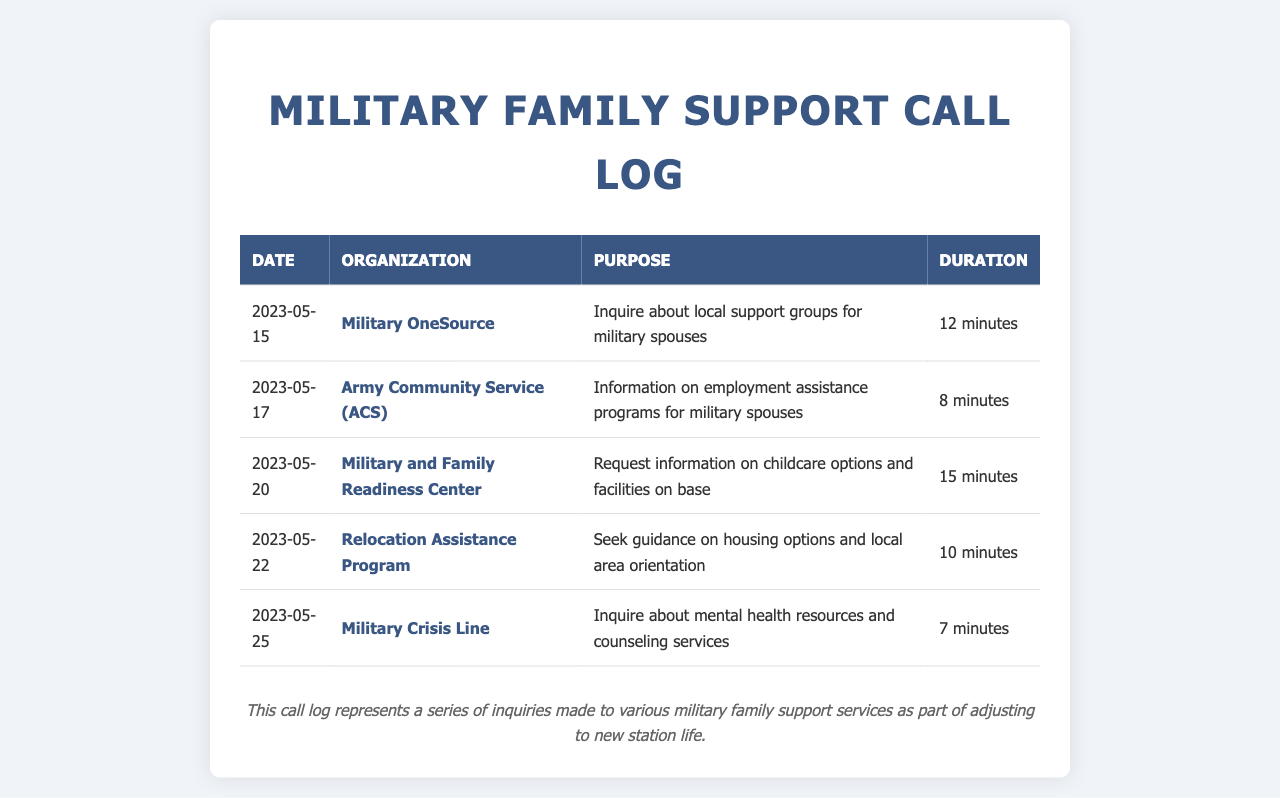What is the date of the first call? The first call listed in the log takes place on May 15, 2023.
Answer: May 15, 2023 Which organization was contacted for information about local support groups? The log shows that Military OneSource was contacted regarding local support groups.
Answer: Military OneSource How long was the call with the Army Community Service (ACS)? The duration of the call with ACS is mentioned as 8 minutes in the log.
Answer: 8 minutes What type of information was requested from the Military and Family Readiness Center? The caller requested information on childcare options and facilities available on base.
Answer: Childcare options and facilities Which service provided mental health resources and counseling services? The Military Crisis Line is listed as the service providing mental health resources.
Answer: Military Crisis Line How many organizations were contacted in total? There are five organizations listed in the call log, indicating the number of contacts made.
Answer: Five What was the purpose of the call on May 22, 2023? The purpose of the call on May 22 was to seek guidance on housing options and local area orientation.
Answer: Guidance on housing options and local area orientation Which call had the longest duration? The call requesting information on childcare options and facilities took the longest time at 15 minutes.
Answer: 15 minutes What is the main focus of this call log? The call log represents a series of inquiries made to various military family support services.
Answer: Inquiries to military family support services 